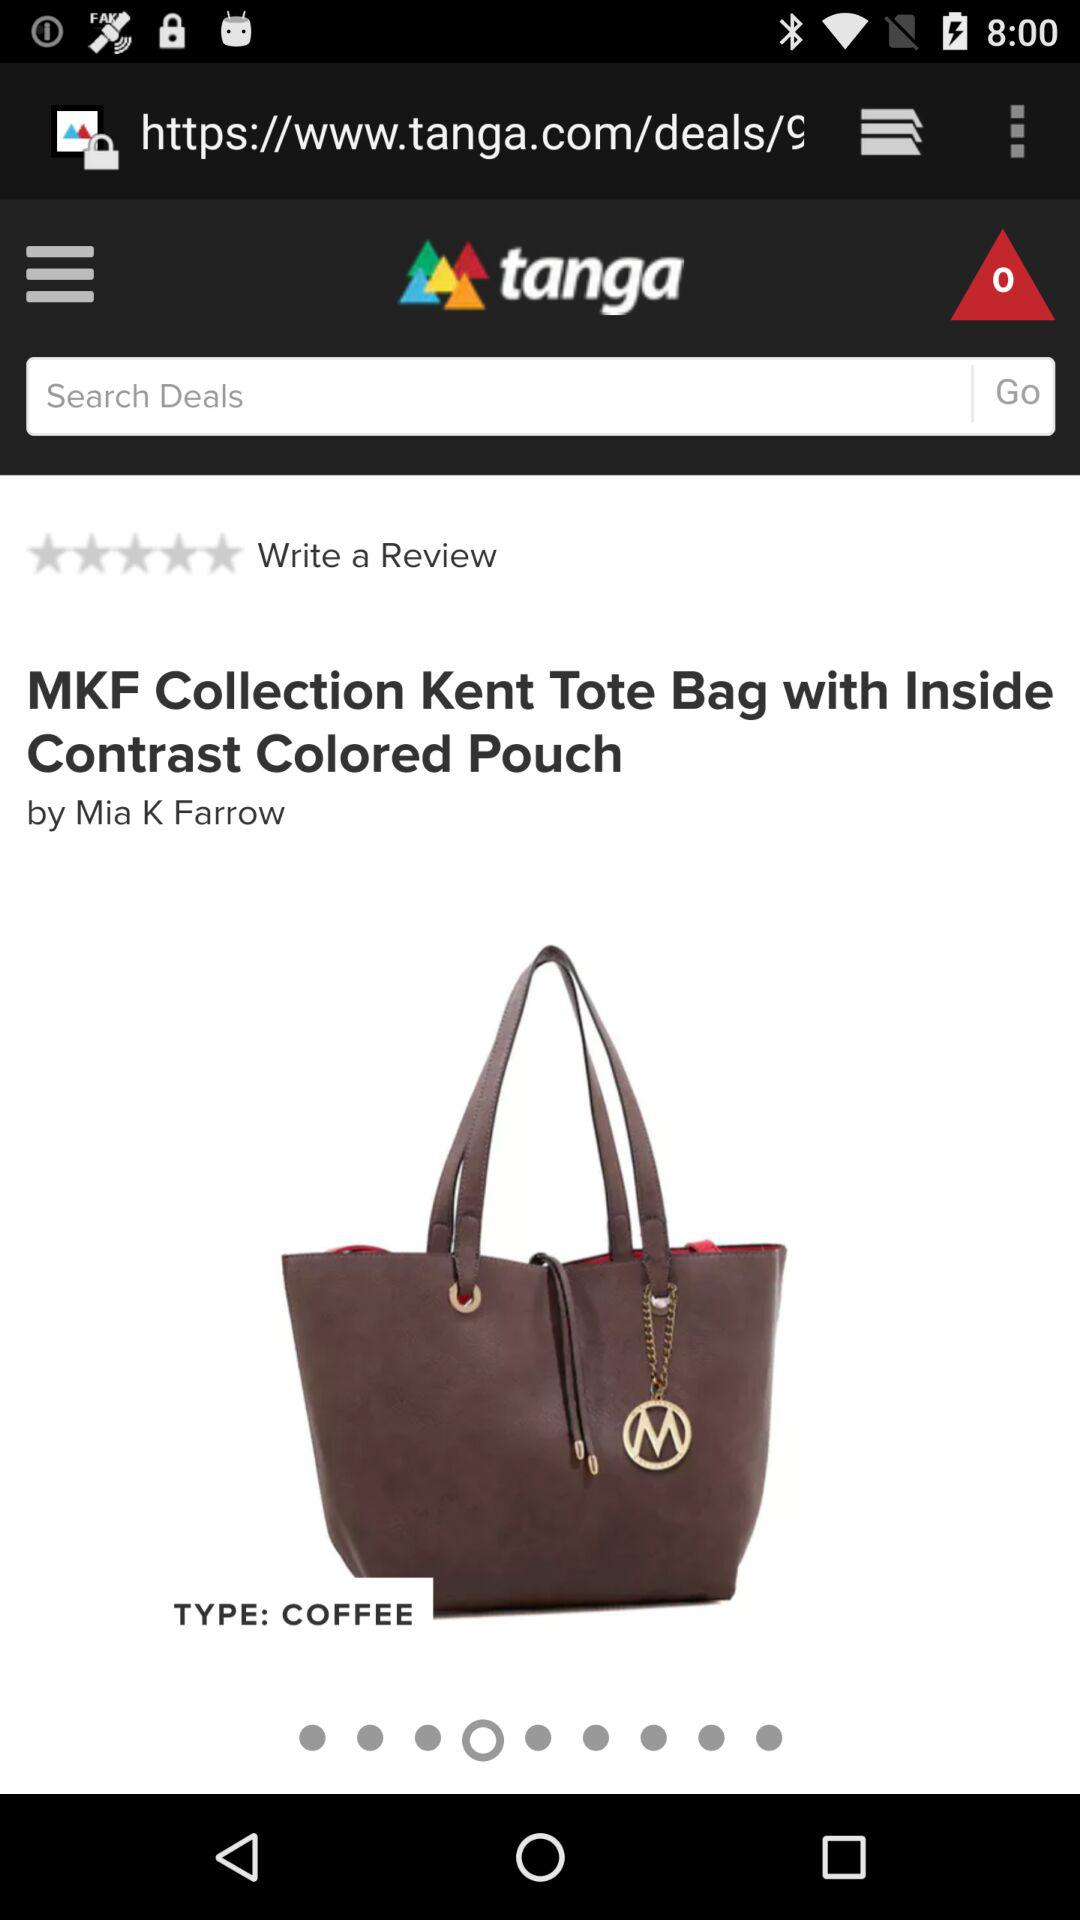What is the rating? The rating is 0 stars. 